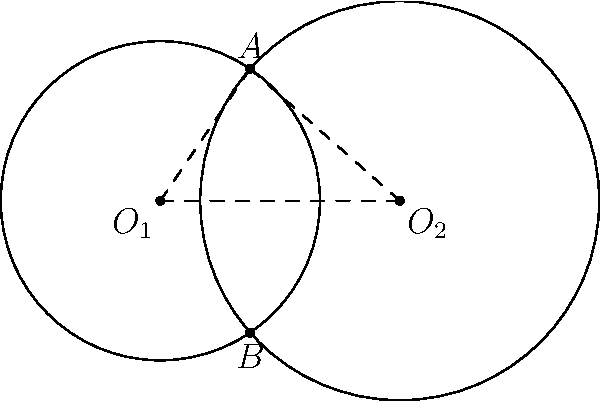Your media company is considering investing in a research project that involves analyzing overlapping coverage areas of two satellite dishes. The coverage areas can be modeled as circular regions. Given two circular coverage areas with radii $r_1 = 2$ km and $r_2 = 2.5$ km, and their centers separated by a distance $d = 3$ km, calculate the area of the overlapping region. This information will help determine the potential audience reach for your new satellite-based media service. Round your answer to the nearest 0.01 km². To solve this problem, we'll use the formula for the area of intersection of two circles. Let's approach this step-by-step:

1) First, we need to calculate the distance $x$ from the center of each circle to the line connecting the intersection points:

   $$x_1 = \frac{r_1^2 - r_2^2 + d^2}{2d} \text{ and } x_2 = d - x_1$$

   $$x_1 = \frac{2^2 - 2.5^2 + 3^2}{2(3)} = 1.0833 \text{ km}$$
   $$x_2 = 3 - 1.0833 = 1.9167 \text{ km}$$

2) Next, we calculate the angle $\theta$ for each circle:

   $$\theta_1 = 2 \arccos(\frac{x_1}{r_1}) \text{ and } \theta_2 = 2 \arccos(\frac{x_2}{r_2})$$

   $$\theta_1 = 2 \arccos(\frac{1.0833}{2}) = 2.0944 \text{ radians}$$
   $$\theta_2 = 2 \arccos(\frac{1.9167}{2.5}) = 1.8395 \text{ radians}$$

3) Now we can calculate the area of each sector:

   $$A_1 = \frac{1}{2}r_1^2\theta_1 = \frac{1}{2}(2^2)(2.0944) = 4.1888 \text{ km}^2$$
   $$A_2 = \frac{1}{2}r_2^2\theta_2 = \frac{1}{2}(2.5^2)(1.8395) = 5.7484 \text{ km}^2$$

4) We also need to calculate the area of the triangles:

   $$T_1 = \frac{1}{2}r_1^2\sin(\theta_1) = \frac{1}{2}(2^2)\sin(2.0944) = 1.8541 \text{ km}^2$$
   $$T_2 = \frac{1}{2}r_2^2\sin(\theta_2) = \frac{1}{2}(2.5^2)\sin(1.8395) = 2.7604 \text{ km}^2$$

5) Finally, the area of intersection is:

   $$A_{intersection} = A_1 + A_2 - (T_1 + T_2)$$
   $$A_{intersection} = 4.1888 + 5.7484 - (1.8541 + 2.7604) = 5.3227 \text{ km}^2$$

6) Rounding to the nearest 0.01 km²:

   $$A_{intersection} \approx 5.32 \text{ km}^2$$
Answer: 5.32 km² 